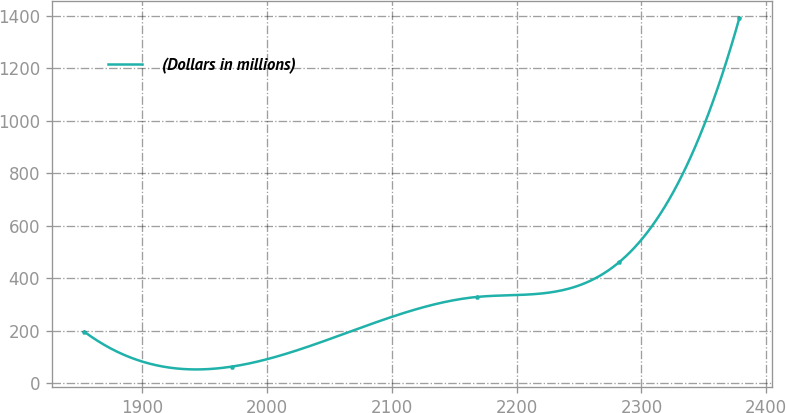Convert chart to OTSL. <chart><loc_0><loc_0><loc_500><loc_500><line_chart><ecel><fcel>(Dollars in millions)<nl><fcel>1853.48<fcel>196.11<nl><fcel>1971.65<fcel>63.45<nl><fcel>2168.28<fcel>328.77<nl><fcel>2282.28<fcel>461.43<nl><fcel>2378.52<fcel>1390.09<nl></chart> 